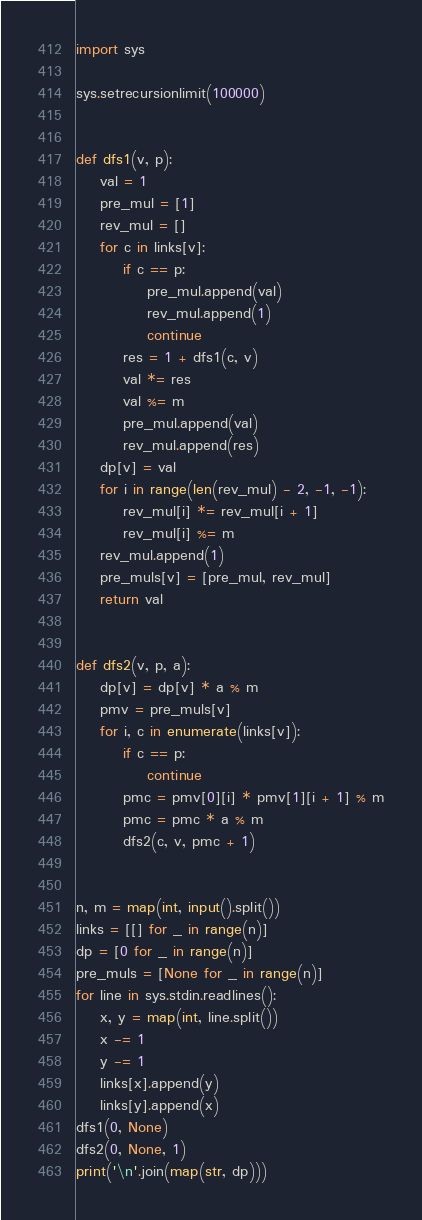<code> <loc_0><loc_0><loc_500><loc_500><_Python_>import sys
 
sys.setrecursionlimit(100000)
 
 
def dfs1(v, p):
    val = 1
    pre_mul = [1]
    rev_mul = []
    for c in links[v]:
        if c == p:
            pre_mul.append(val)
            rev_mul.append(1)
            continue
        res = 1 + dfs1(c, v)
        val *= res
        val %= m
        pre_mul.append(val)
        rev_mul.append(res)
    dp[v] = val
    for i in range(len(rev_mul) - 2, -1, -1):
        rev_mul[i] *= rev_mul[i + 1]
        rev_mul[i] %= m
    rev_mul.append(1)
    pre_muls[v] = [pre_mul, rev_mul]
    return val
 
 
def dfs2(v, p, a):
    dp[v] = dp[v] * a % m
    pmv = pre_muls[v]
    for i, c in enumerate(links[v]):
        if c == p:
            continue
        pmc = pmv[0][i] * pmv[1][i + 1] % m
        pmc = pmc * a % m
        dfs2(c, v, pmc + 1)
 
 
n, m = map(int, input().split())
links = [[] for _ in range(n)]
dp = [0 for _ in range(n)]
pre_muls = [None for _ in range(n)]
for line in sys.stdin.readlines():
    x, y = map(int, line.split())
    x -= 1
    y -= 1
    links[x].append(y)
    links[y].append(x)
dfs1(0, None)
dfs2(0, None, 1)
print('\n'.join(map(str, dp)))</code> 